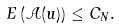Convert formula to latex. <formula><loc_0><loc_0><loc_500><loc_500>E \left ( \mathcal { A } ( u ) \right ) \leq C _ { N } .</formula> 